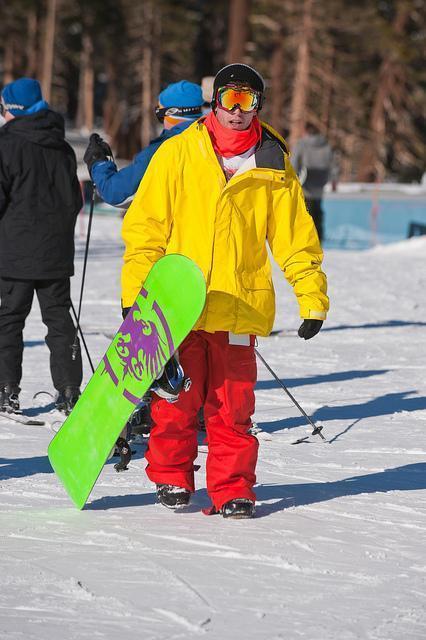How many poles are there?
Give a very brief answer. 2. How many people are there?
Give a very brief answer. 4. 